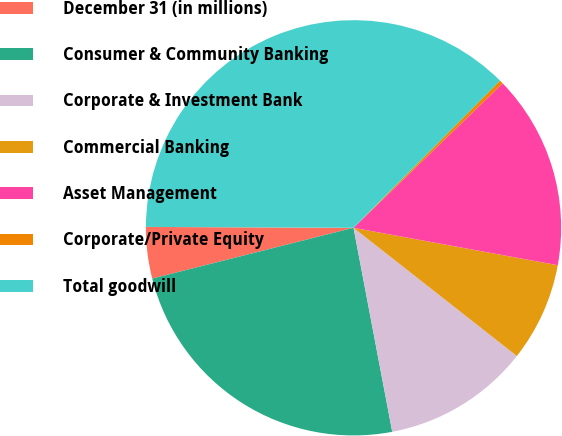<chart> <loc_0><loc_0><loc_500><loc_500><pie_chart><fcel>December 31 (in millions)<fcel>Consumer & Community Banking<fcel>Corporate & Investment Bank<fcel>Commercial Banking<fcel>Asset Management<fcel>Corporate/Private Equity<fcel>Total goodwill<nl><fcel>4.0%<fcel>24.05%<fcel>11.42%<fcel>7.71%<fcel>15.13%<fcel>0.29%<fcel>37.39%<nl></chart> 